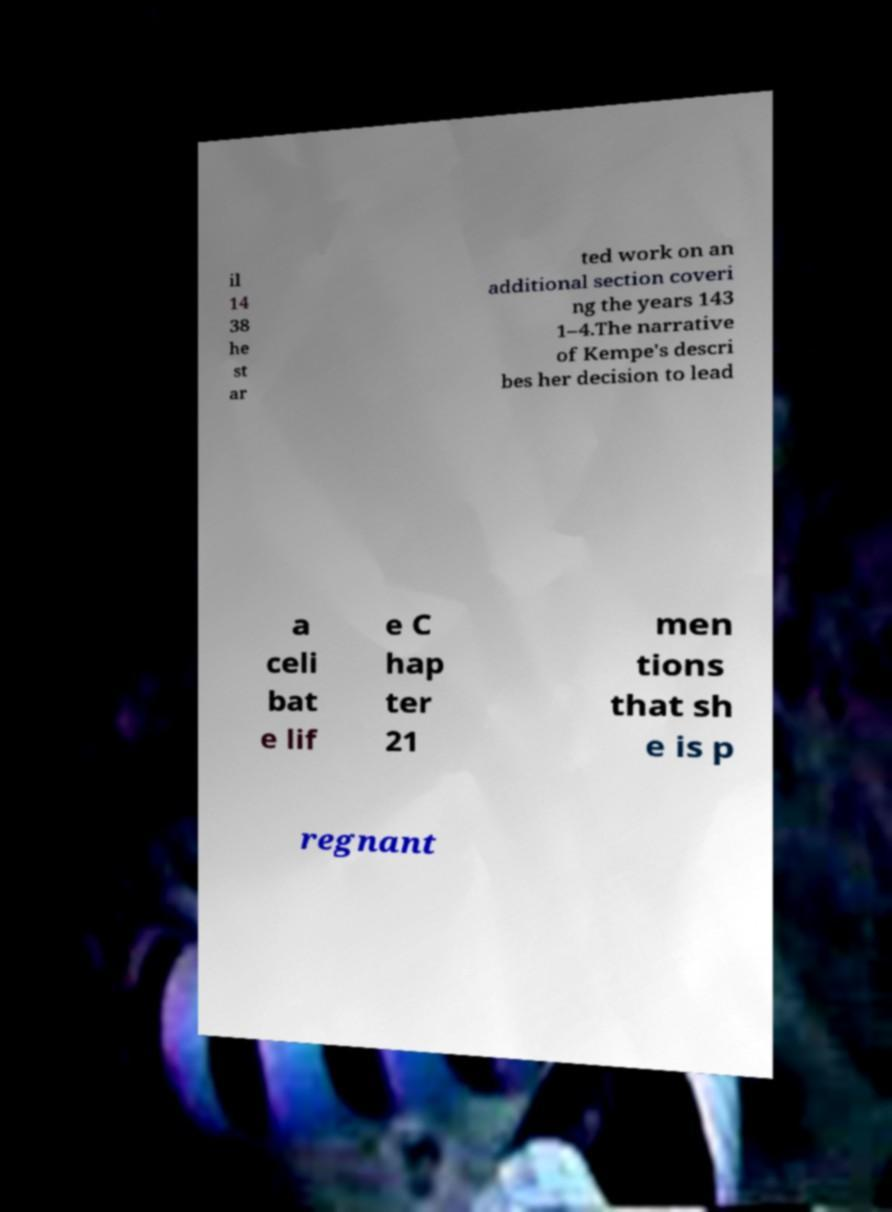Could you assist in decoding the text presented in this image and type it out clearly? il 14 38 he st ar ted work on an additional section coveri ng the years 143 1–4.The narrative of Kempe's descri bes her decision to lead a celi bat e lif e C hap ter 21 men tions that sh e is p regnant 